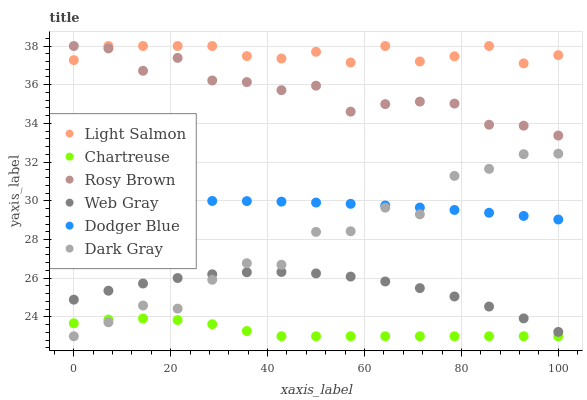Does Chartreuse have the minimum area under the curve?
Answer yes or no. Yes. Does Light Salmon have the maximum area under the curve?
Answer yes or no. Yes. Does Web Gray have the minimum area under the curve?
Answer yes or no. No. Does Web Gray have the maximum area under the curve?
Answer yes or no. No. Is Dodger Blue the smoothest?
Answer yes or no. Yes. Is Dark Gray the roughest?
Answer yes or no. Yes. Is Web Gray the smoothest?
Answer yes or no. No. Is Web Gray the roughest?
Answer yes or no. No. Does Dark Gray have the lowest value?
Answer yes or no. Yes. Does Web Gray have the lowest value?
Answer yes or no. No. Does Rosy Brown have the highest value?
Answer yes or no. Yes. Does Web Gray have the highest value?
Answer yes or no. No. Is Dark Gray less than Light Salmon?
Answer yes or no. Yes. Is Light Salmon greater than Dodger Blue?
Answer yes or no. Yes. Does Dark Gray intersect Chartreuse?
Answer yes or no. Yes. Is Dark Gray less than Chartreuse?
Answer yes or no. No. Is Dark Gray greater than Chartreuse?
Answer yes or no. No. Does Dark Gray intersect Light Salmon?
Answer yes or no. No. 